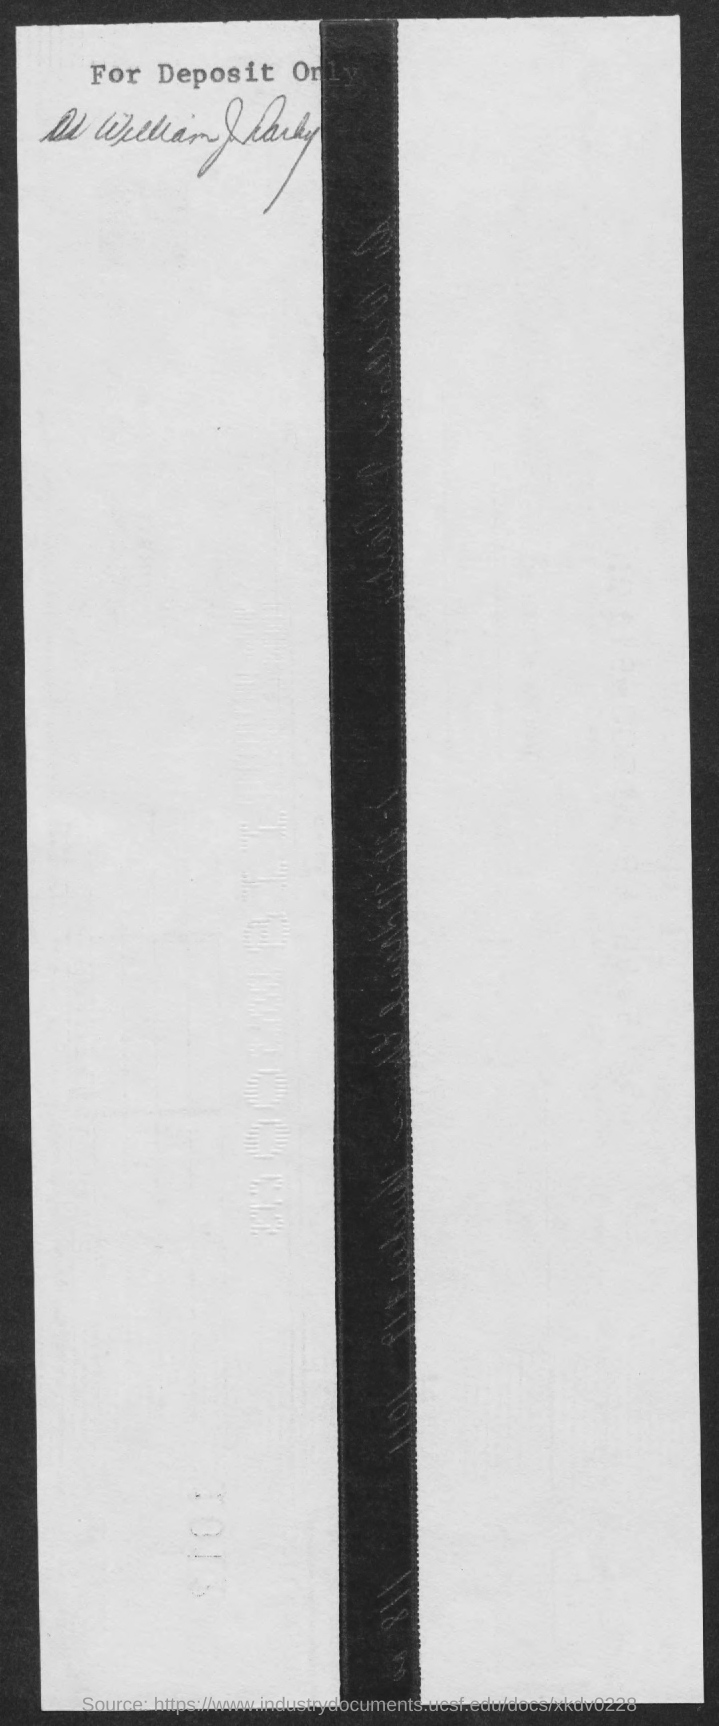What is the first title in the document?
Your answer should be compact. For deposit only. 